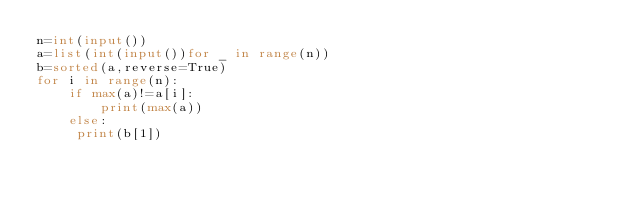<code> <loc_0><loc_0><loc_500><loc_500><_Python_>n=int(input())
a=list(int(input())for _ in range(n))
b=sorted(a,reverse=True)
for i in range(n):
    if max(a)!=a[i]:
        print(max(a))
    else:
     print(b[1])</code> 